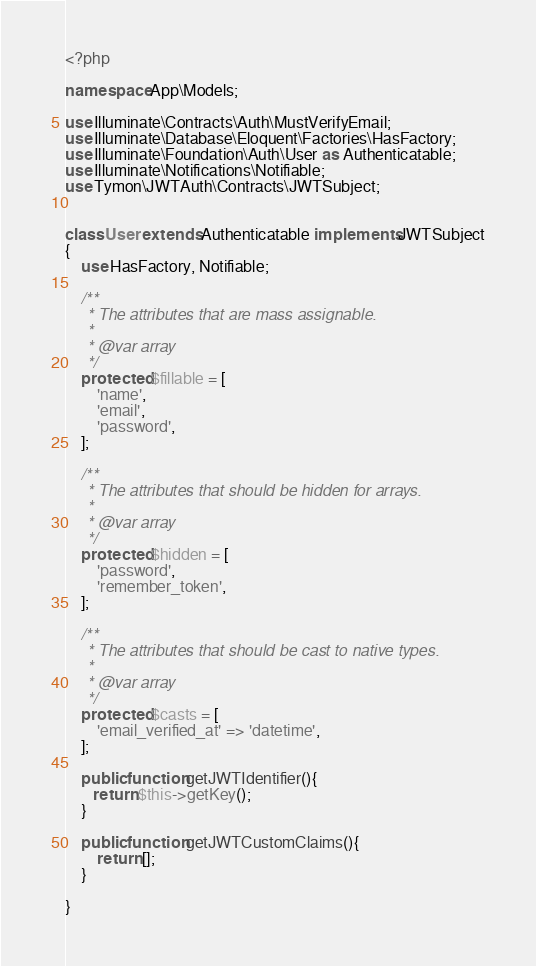<code> <loc_0><loc_0><loc_500><loc_500><_PHP_><?php

namespace App\Models;

use Illuminate\Contracts\Auth\MustVerifyEmail;
use Illuminate\Database\Eloquent\Factories\HasFactory;
use Illuminate\Foundation\Auth\User as Authenticatable;
use Illuminate\Notifications\Notifiable;
use Tymon\JWTAuth\Contracts\JWTSubject;


class User extends Authenticatable implements JWTSubject
{
    use HasFactory, Notifiable;

    /**
     * The attributes that are mass assignable.
     *
     * @var array
     */
    protected $fillable = [
        'name',
        'email',
        'password',
    ];

    /**
     * The attributes that should be hidden for arrays.
     *
     * @var array
     */
    protected $hidden = [
        'password',
        'remember_token',
    ];

    /**
     * The attributes that should be cast to native types.
     *
     * @var array
     */
    protected $casts = [
        'email_verified_at' => 'datetime',
    ];

    public function getJWTIdentifier(){
       return $this->getKey();
    }

    public function getJWTCustomClaims(){
        return [];
    }

}
</code> 